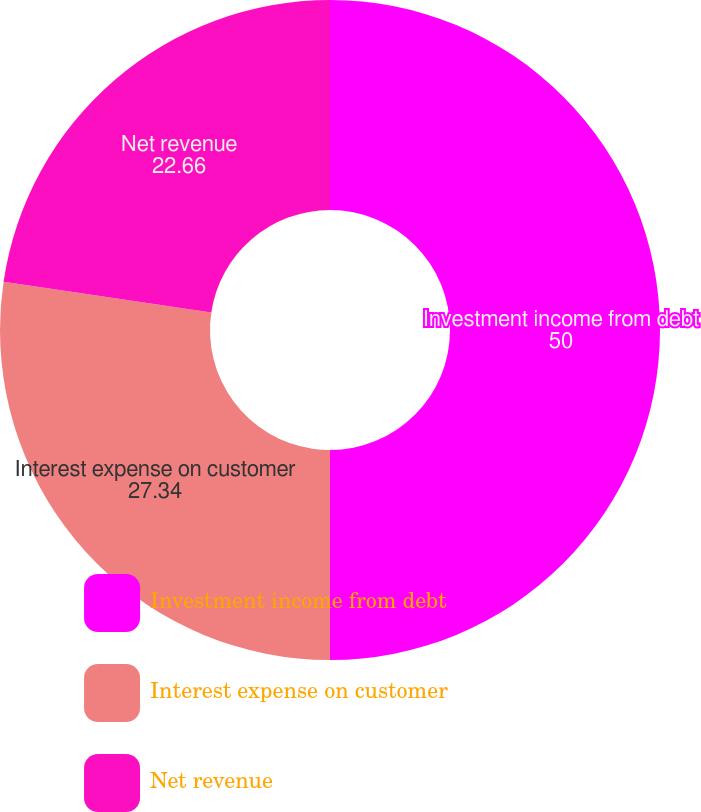Convert chart. <chart><loc_0><loc_0><loc_500><loc_500><pie_chart><fcel>Investment income from debt<fcel>Interest expense on customer<fcel>Net revenue<nl><fcel>50.0%<fcel>27.34%<fcel>22.66%<nl></chart> 